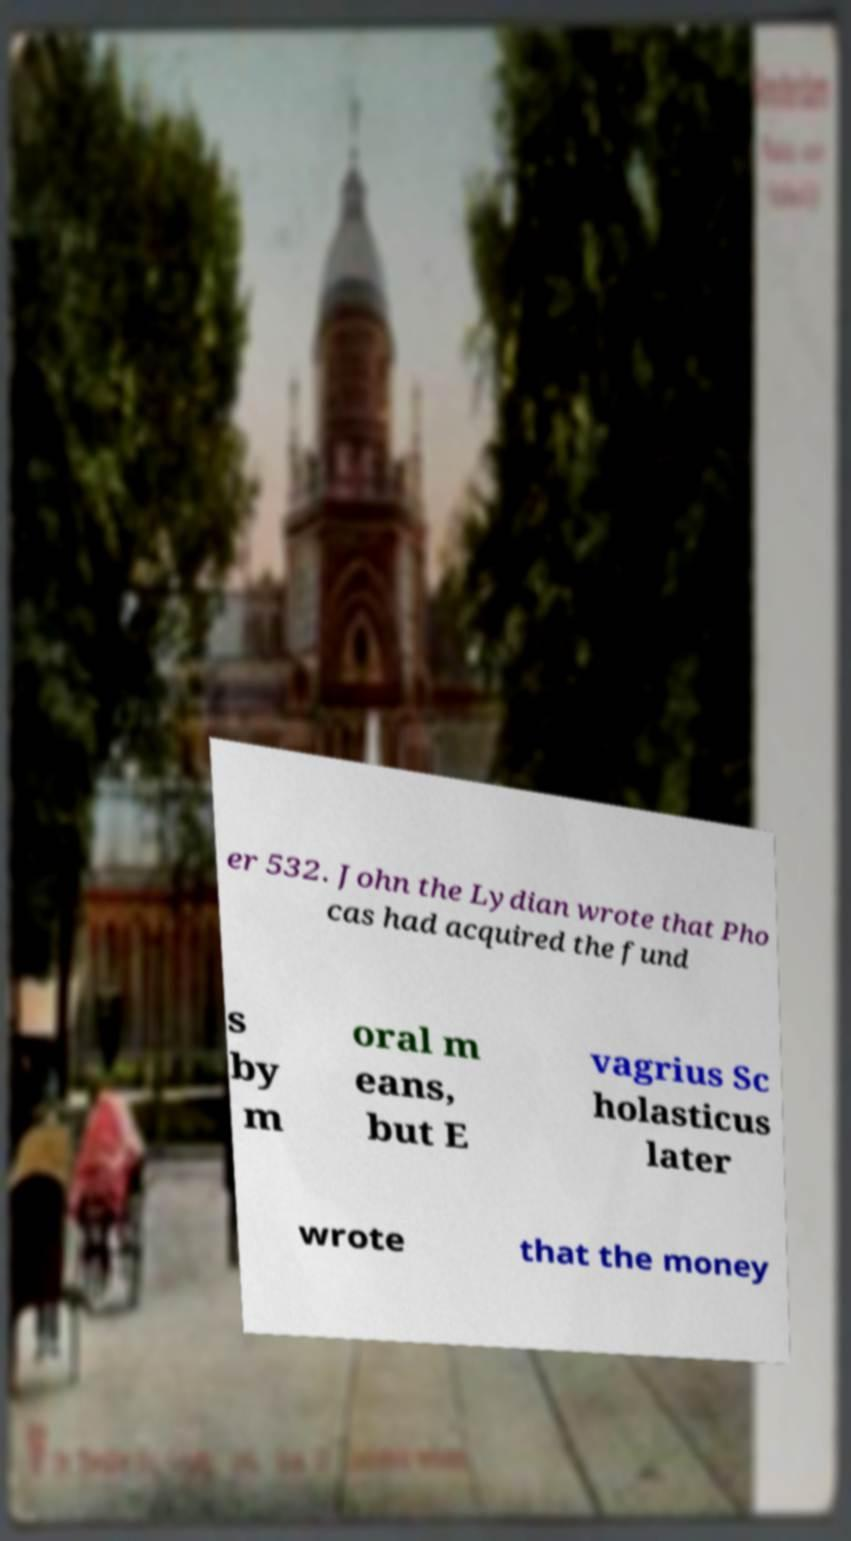Could you extract and type out the text from this image? er 532. John the Lydian wrote that Pho cas had acquired the fund s by m oral m eans, but E vagrius Sc holasticus later wrote that the money 